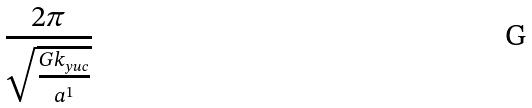Convert formula to latex. <formula><loc_0><loc_0><loc_500><loc_500>\frac { 2 \pi } { \sqrt { \frac { G k _ { y u c } } { a ^ { 1 } } } }</formula> 